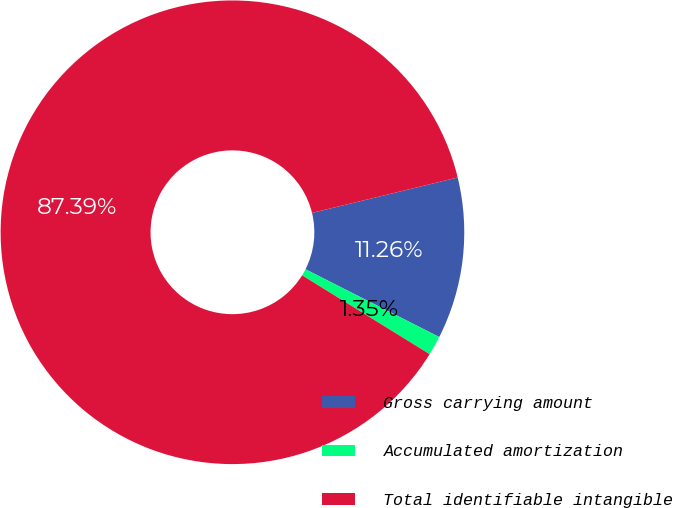Convert chart to OTSL. <chart><loc_0><loc_0><loc_500><loc_500><pie_chart><fcel>Gross carrying amount<fcel>Accumulated amortization<fcel>Total identifiable intangible<nl><fcel>11.26%<fcel>1.35%<fcel>87.39%<nl></chart> 